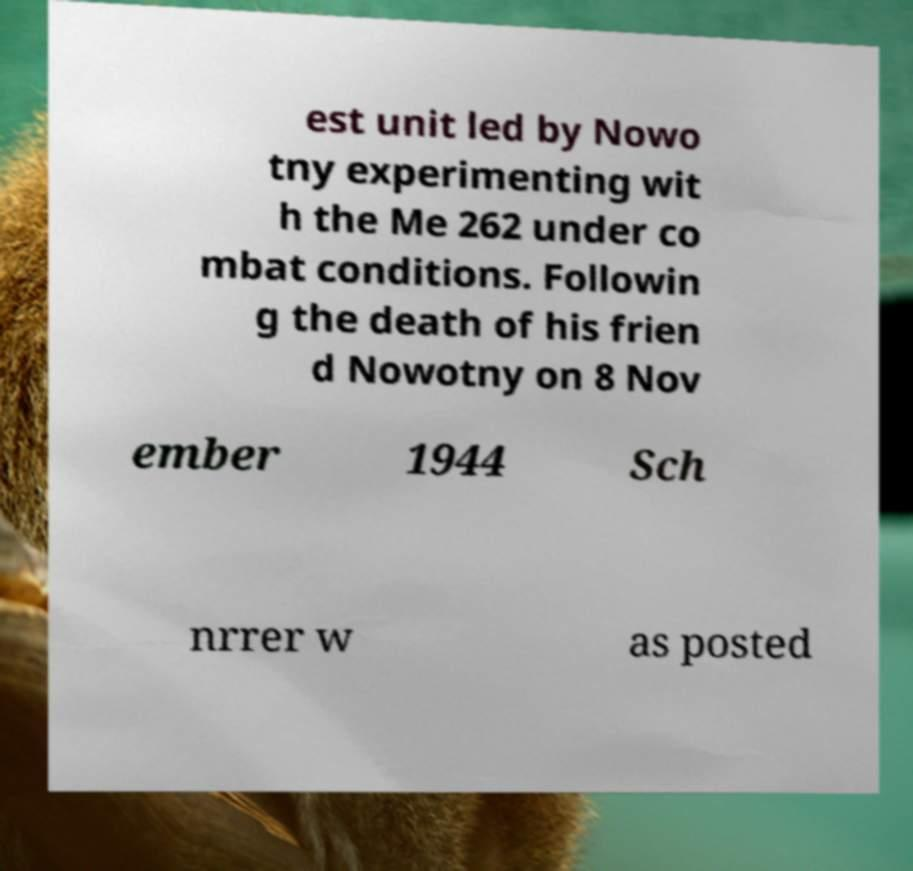Could you assist in decoding the text presented in this image and type it out clearly? est unit led by Nowo tny experimenting wit h the Me 262 under co mbat conditions. Followin g the death of his frien d Nowotny on 8 Nov ember 1944 Sch nrrer w as posted 